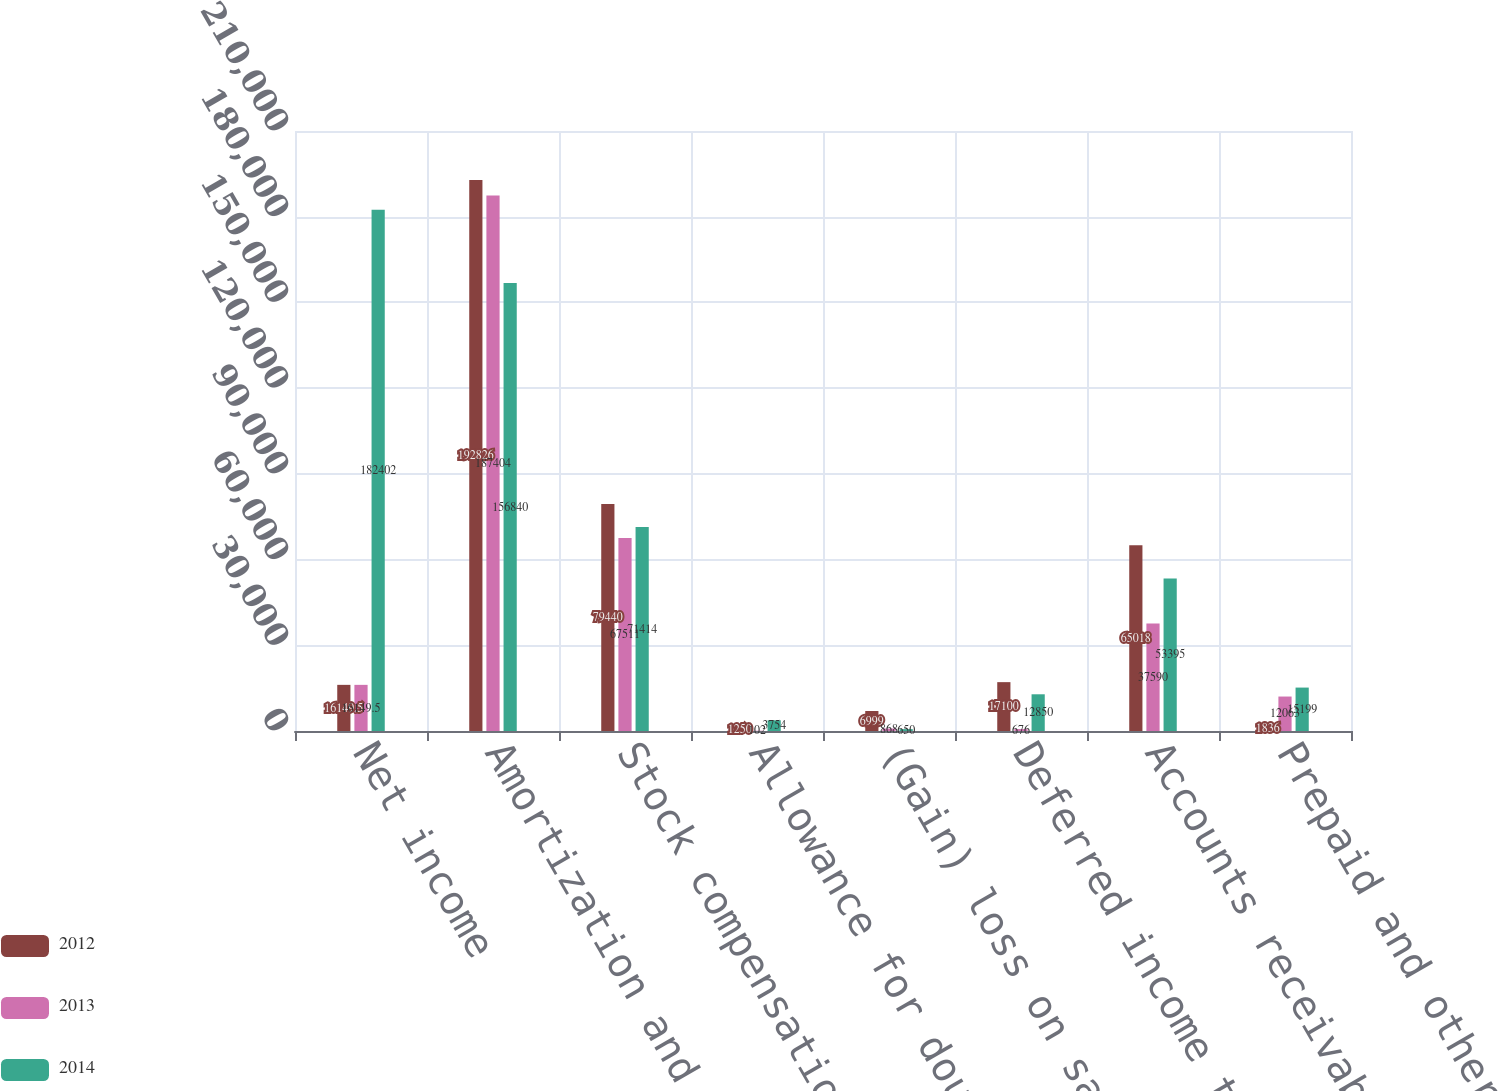<chart> <loc_0><loc_0><loc_500><loc_500><stacked_bar_chart><ecel><fcel>Net income<fcel>Amortization and depreciation<fcel>Stock compensation<fcel>Allowance for doubtful<fcel>(Gain) loss on sale of<fcel>Deferred income taxes<fcel>Accounts receivable<fcel>Prepaid and other current<nl><fcel>2012<fcel>16149.5<fcel>192826<fcel>79440<fcel>1250<fcel>6999<fcel>17100<fcel>65018<fcel>1836<nl><fcel>2013<fcel>16149.5<fcel>187404<fcel>67511<fcel>102<fcel>868<fcel>676<fcel>37590<fcel>12063<nl><fcel>2014<fcel>182402<fcel>156840<fcel>71414<fcel>3754<fcel>650<fcel>12850<fcel>53395<fcel>15199<nl></chart> 